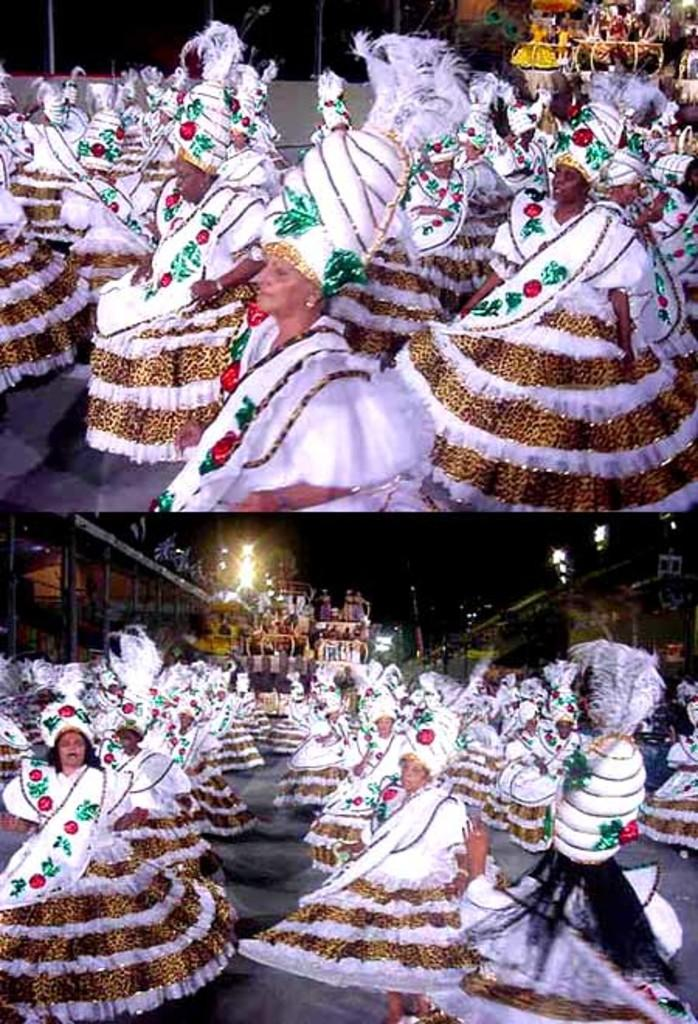How many people are in the image? There is a group of people in the image. What are the people wearing? The people are wearing costumes. Where are the people standing? The people are standing on the ground. What can be seen in the image that provides illumination? There are lights visible in the image. What structures are present in the image? There are poles and buildings in the image. What type of bread can be seen in the image? There is no bread present in the image. How does the whistle affect the people in the image? There is no whistle present in the image, so it cannot affect the people. 